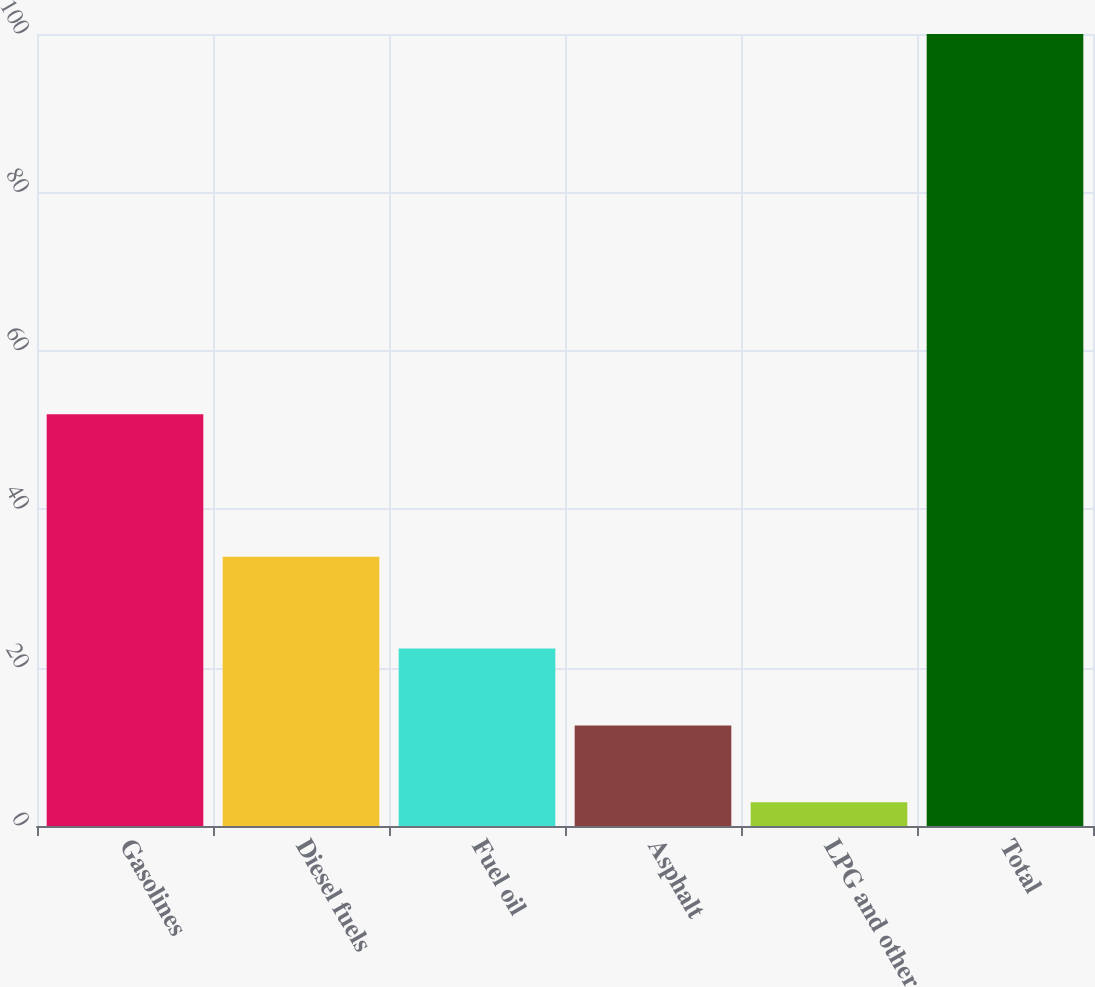Convert chart to OTSL. <chart><loc_0><loc_0><loc_500><loc_500><bar_chart><fcel>Gasolines<fcel>Diesel fuels<fcel>Fuel oil<fcel>Asphalt<fcel>LPG and other<fcel>Total<nl><fcel>52<fcel>34<fcel>22.4<fcel>12.7<fcel>3<fcel>100<nl></chart> 